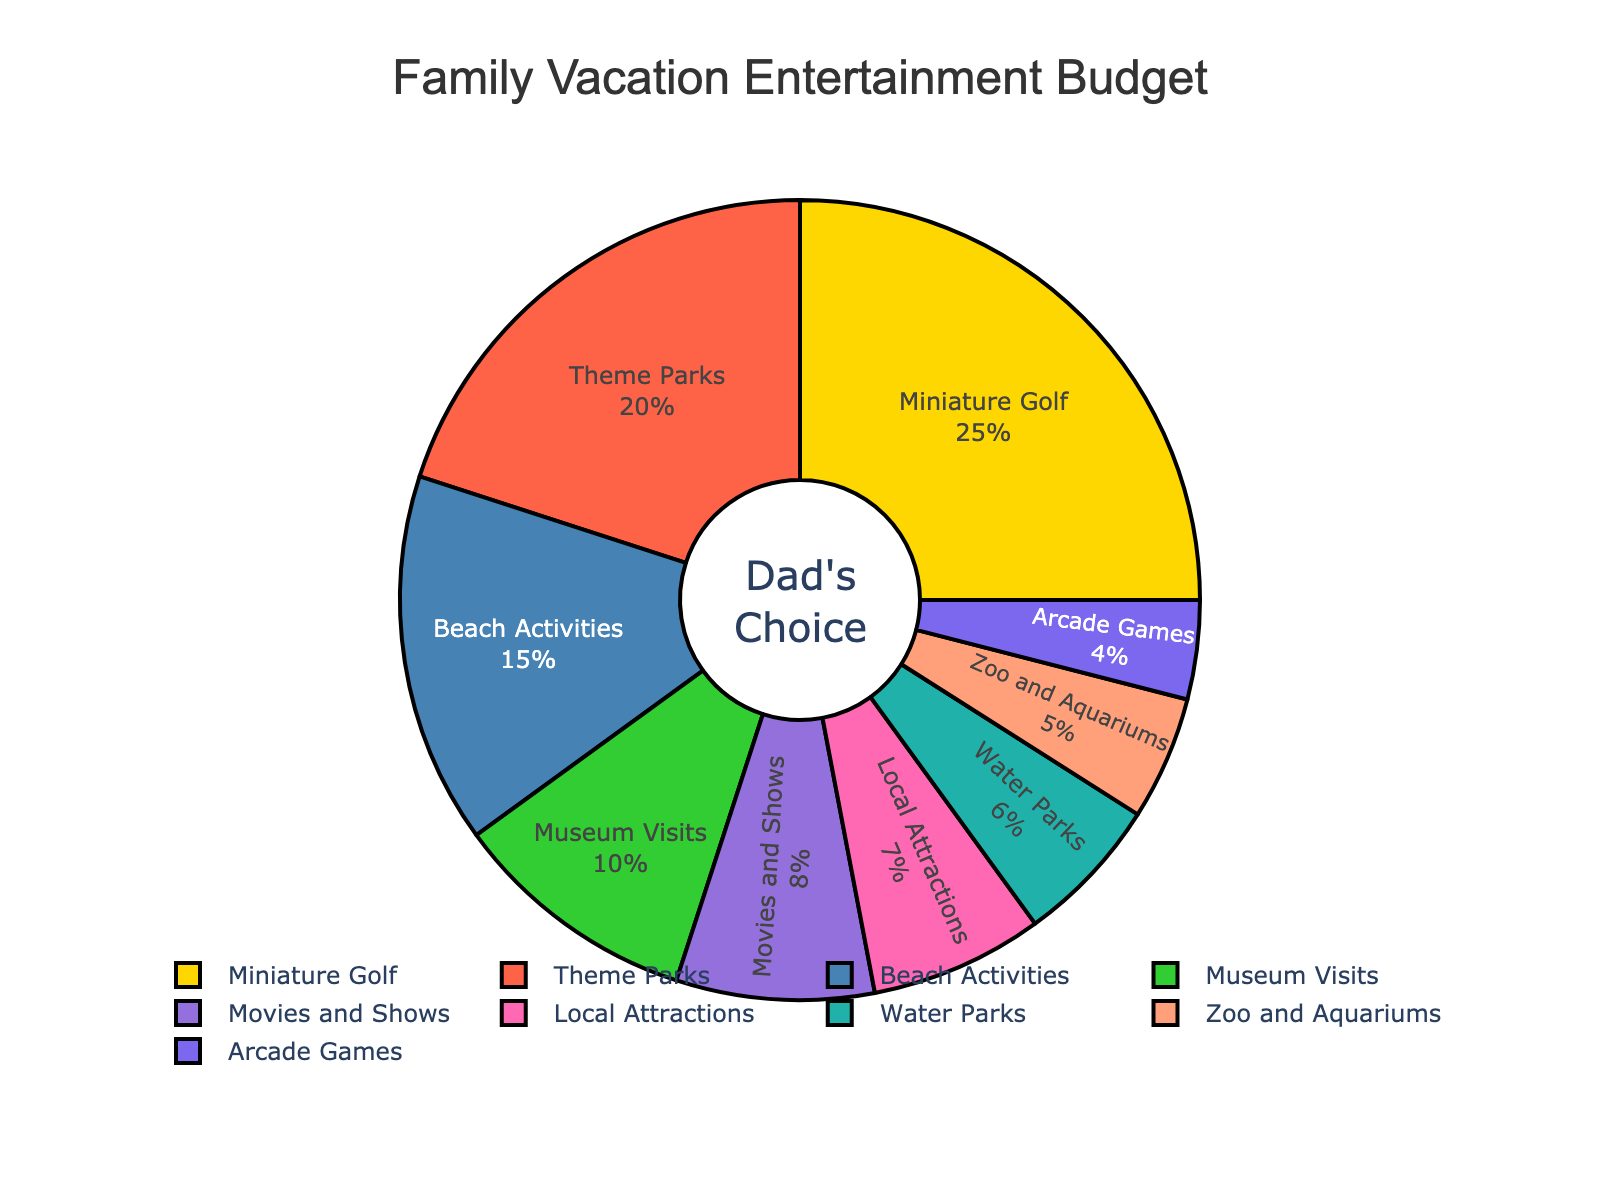What percentage of the vacation budget is allocated to Movies and Shows and Zoo and Aquariums combined? Add the percentages for Movies and Shows (8%) and Zoo and Aquariums (5%). 8 + 5 = 13
Answer: 13% Which activity gets the highest allocation of the vacation budget? Identify the sector with the largest percentage. Miniature Golf has the highest allocation with 25%
Answer: Miniature Golf Are more funds allocated to Beach Activities or Local Attractions? Compare the percentages: Beach Activities (15%) vs. Local Attractions (7%). 15 is greater than 7
Answer: Beach Activities How much more budget is allocated to Theme Parks compared to Arcade Games? Subtract the percentage for Arcade Games (4%) from Theme Parks (20%). 20 - 4 = 16
Answer: 16% What's the total percentage of the vacation budget allocated to water-based activities (Beach Activities and Water Parks)? Add the percentages for Beach Activities (15%) and Water Parks (6%). 15 + 6 = 21
Answer: 21% Which activity has the smallest allocation in the budget? Identify the sector with the smallest percentage. Arcade Games have the smallest allocation with 4%
Answer: Arcade Games Compare the budget allocation for Museums Visits to Local Attractions. Which one has a higher allocation? Compare the percentages: Museum Visits (10%) vs. Local Attractions (7%). 10 is greater than 7
Answer: Museum Visits What is the average percentage allocation for Zoo and Aquariums, Arcade Games, and Local Attractions? Add the percentages: Zoo and Aquariums (5%), Arcade Games (4%), Local Attractions (7%). Sum: 5 + 4 + 7 = 16. Divide by the number of activities: 16 / 3 ≈ 5.33
Answer: 5.33% What color represents the Beach Activities in the pie chart? Beach Activities is represented by the color blue as indicated in the chart legend
Answer: Blue How much more budget is allocated to Miniature Golf compared to Museum Visits and Movies and Shows combined? Add the percentages for Museum Visits (10%) and Movies and Shows (8%). Sum: 10 + 8 = 18. Subtract this sum from the percentage for Miniature Golf (25%). 25 - 18 = 7
Answer: 7% 